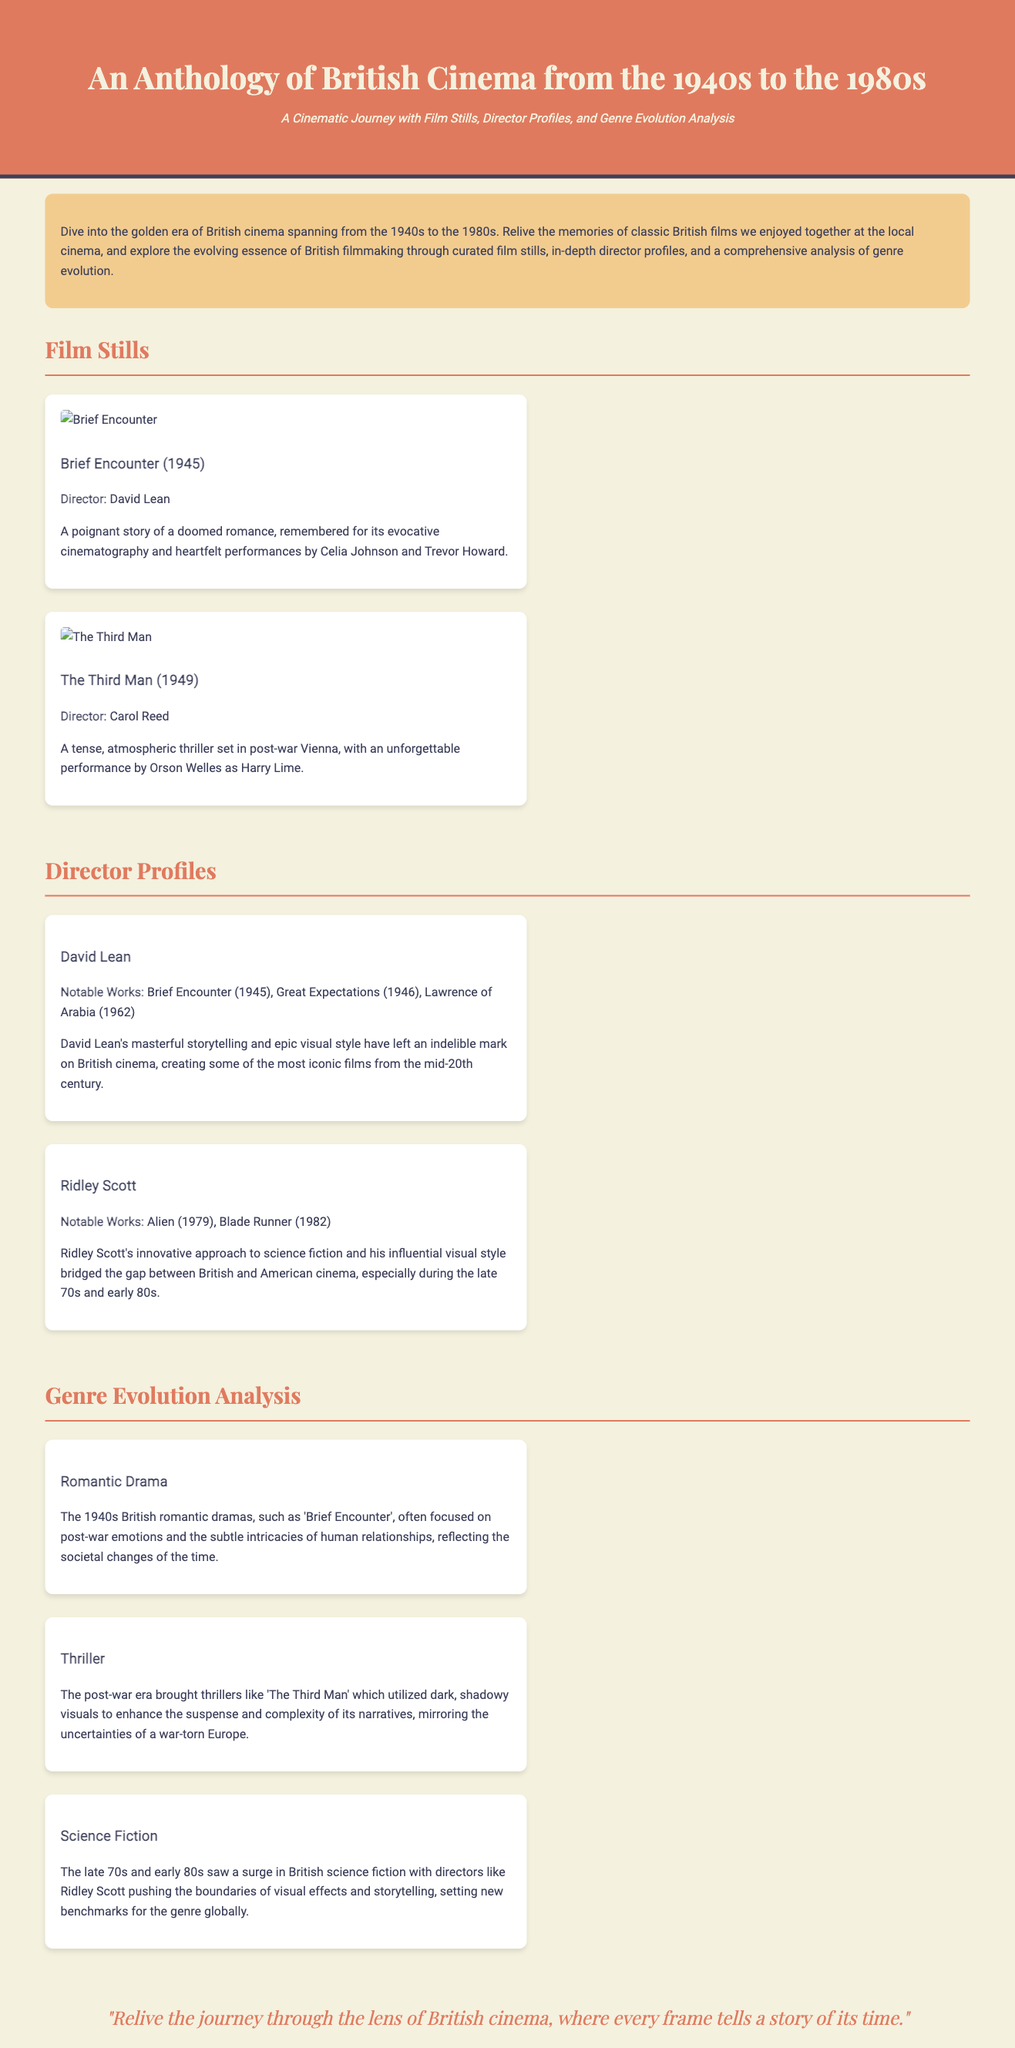What is the title of the anthology? The title of the anthology is presented at the top of the document, which is "An Anthology of British Cinema from the 1940s to the 1980s."
Answer: An Anthology of British Cinema from the 1940s to the 1980s Who directed "Brief Encounter"? The director of "Brief Encounter" is listed in the film still section along with its details.
Answer: David Lean What year was "The Third Man" released? The year of release for "The Third Man" can be found next to its title in the film stills section.
Answer: 1949 What genre is associated with Ridley Scott in the director profiles? The directors have notable works associated with specific genres mentioned in their profiles.
Answer: Science Fiction How many notable works are listed for David Lean? The document lists the notable works of David Lean in a specific section of the director profiles.
Answer: Three Which film is mentioned as an example of science fiction in the genre evolution analysis? The document provides examples of genres and mentions specific films under each category in the genre evolution section.
Answer: Alien What is the background color of the header? The header's background color is specified in the document's code for aesthetics.
Answer: #e07a5f What type of films are discussed in the genre evolution section? The genre evolution section details specific film genres that evolved through the decades as indicated in the section headers.
Answer: Romantic Drama, Thriller, Science Fiction 